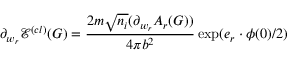Convert formula to latex. <formula><loc_0><loc_0><loc_500><loc_500>\partial _ { w _ { r } } \mathcal { E } ^ { ( c l ) } ( G ) = \frac { 2 m \sqrt { n _ { i } } ( \partial _ { w _ { r } } A _ { r } ( G ) ) } { 4 \pi b ^ { 2 } } \exp ( e _ { r } \cdot \phi ( 0 ) / 2 )</formula> 